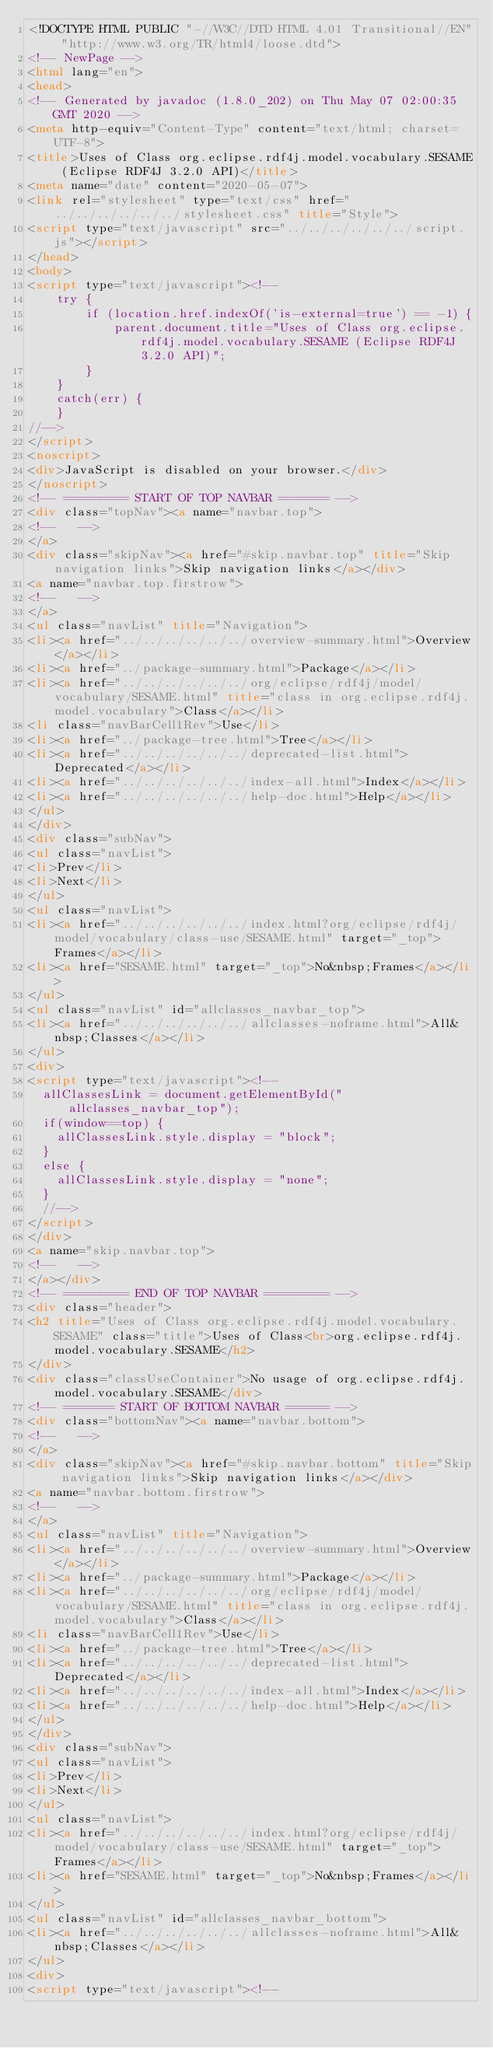<code> <loc_0><loc_0><loc_500><loc_500><_HTML_><!DOCTYPE HTML PUBLIC "-//W3C//DTD HTML 4.01 Transitional//EN" "http://www.w3.org/TR/html4/loose.dtd">
<!-- NewPage -->
<html lang="en">
<head>
<!-- Generated by javadoc (1.8.0_202) on Thu May 07 02:00:35 GMT 2020 -->
<meta http-equiv="Content-Type" content="text/html; charset=UTF-8">
<title>Uses of Class org.eclipse.rdf4j.model.vocabulary.SESAME (Eclipse RDF4J 3.2.0 API)</title>
<meta name="date" content="2020-05-07">
<link rel="stylesheet" type="text/css" href="../../../../../../stylesheet.css" title="Style">
<script type="text/javascript" src="../../../../../../script.js"></script>
</head>
<body>
<script type="text/javascript"><!--
    try {
        if (location.href.indexOf('is-external=true') == -1) {
            parent.document.title="Uses of Class org.eclipse.rdf4j.model.vocabulary.SESAME (Eclipse RDF4J 3.2.0 API)";
        }
    }
    catch(err) {
    }
//-->
</script>
<noscript>
<div>JavaScript is disabled on your browser.</div>
</noscript>
<!-- ========= START OF TOP NAVBAR ======= -->
<div class="topNav"><a name="navbar.top">
<!--   -->
</a>
<div class="skipNav"><a href="#skip.navbar.top" title="Skip navigation links">Skip navigation links</a></div>
<a name="navbar.top.firstrow">
<!--   -->
</a>
<ul class="navList" title="Navigation">
<li><a href="../../../../../../overview-summary.html">Overview</a></li>
<li><a href="../package-summary.html">Package</a></li>
<li><a href="../../../../../../org/eclipse/rdf4j/model/vocabulary/SESAME.html" title="class in org.eclipse.rdf4j.model.vocabulary">Class</a></li>
<li class="navBarCell1Rev">Use</li>
<li><a href="../package-tree.html">Tree</a></li>
<li><a href="../../../../../../deprecated-list.html">Deprecated</a></li>
<li><a href="../../../../../../index-all.html">Index</a></li>
<li><a href="../../../../../../help-doc.html">Help</a></li>
</ul>
</div>
<div class="subNav">
<ul class="navList">
<li>Prev</li>
<li>Next</li>
</ul>
<ul class="navList">
<li><a href="../../../../../../index.html?org/eclipse/rdf4j/model/vocabulary/class-use/SESAME.html" target="_top">Frames</a></li>
<li><a href="SESAME.html" target="_top">No&nbsp;Frames</a></li>
</ul>
<ul class="navList" id="allclasses_navbar_top">
<li><a href="../../../../../../allclasses-noframe.html">All&nbsp;Classes</a></li>
</ul>
<div>
<script type="text/javascript"><!--
  allClassesLink = document.getElementById("allclasses_navbar_top");
  if(window==top) {
    allClassesLink.style.display = "block";
  }
  else {
    allClassesLink.style.display = "none";
  }
  //-->
</script>
</div>
<a name="skip.navbar.top">
<!--   -->
</a></div>
<!-- ========= END OF TOP NAVBAR ========= -->
<div class="header">
<h2 title="Uses of Class org.eclipse.rdf4j.model.vocabulary.SESAME" class="title">Uses of Class<br>org.eclipse.rdf4j.model.vocabulary.SESAME</h2>
</div>
<div class="classUseContainer">No usage of org.eclipse.rdf4j.model.vocabulary.SESAME</div>
<!-- ======= START OF BOTTOM NAVBAR ====== -->
<div class="bottomNav"><a name="navbar.bottom">
<!--   -->
</a>
<div class="skipNav"><a href="#skip.navbar.bottom" title="Skip navigation links">Skip navigation links</a></div>
<a name="navbar.bottom.firstrow">
<!--   -->
</a>
<ul class="navList" title="Navigation">
<li><a href="../../../../../../overview-summary.html">Overview</a></li>
<li><a href="../package-summary.html">Package</a></li>
<li><a href="../../../../../../org/eclipse/rdf4j/model/vocabulary/SESAME.html" title="class in org.eclipse.rdf4j.model.vocabulary">Class</a></li>
<li class="navBarCell1Rev">Use</li>
<li><a href="../package-tree.html">Tree</a></li>
<li><a href="../../../../../../deprecated-list.html">Deprecated</a></li>
<li><a href="../../../../../../index-all.html">Index</a></li>
<li><a href="../../../../../../help-doc.html">Help</a></li>
</ul>
</div>
<div class="subNav">
<ul class="navList">
<li>Prev</li>
<li>Next</li>
</ul>
<ul class="navList">
<li><a href="../../../../../../index.html?org/eclipse/rdf4j/model/vocabulary/class-use/SESAME.html" target="_top">Frames</a></li>
<li><a href="SESAME.html" target="_top">No&nbsp;Frames</a></li>
</ul>
<ul class="navList" id="allclasses_navbar_bottom">
<li><a href="../../../../../../allclasses-noframe.html">All&nbsp;Classes</a></li>
</ul>
<div>
<script type="text/javascript"><!--</code> 